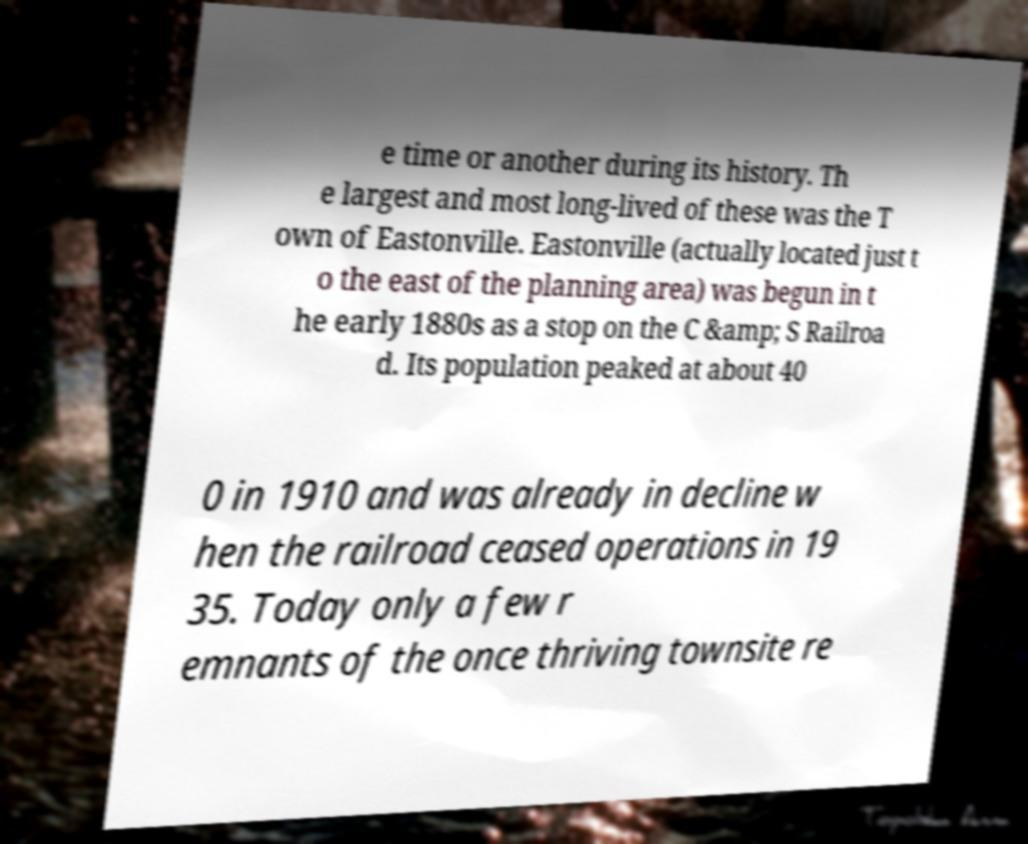For documentation purposes, I need the text within this image transcribed. Could you provide that? e time or another during its history. Th e largest and most long-lived of these was the T own of Eastonville. Eastonville (actually located just t o the east of the planning area) was begun in t he early 1880s as a stop on the C &amp; S Railroa d. Its population peaked at about 40 0 in 1910 and was already in decline w hen the railroad ceased operations in 19 35. Today only a few r emnants of the once thriving townsite re 